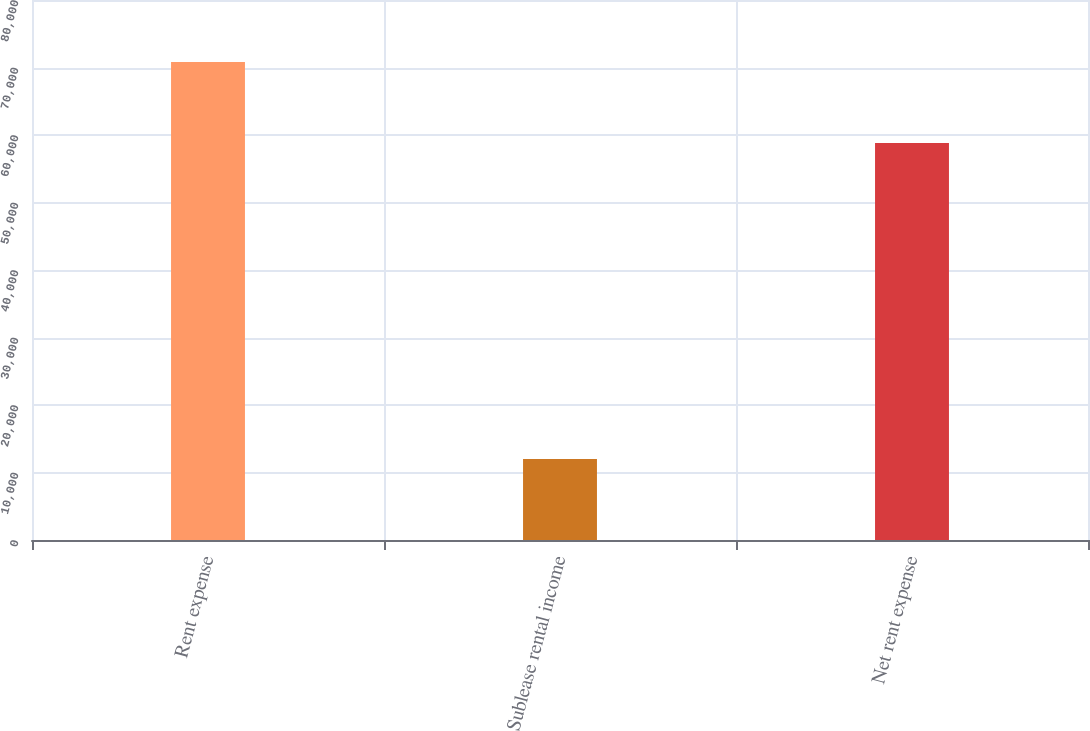<chart> <loc_0><loc_0><loc_500><loc_500><bar_chart><fcel>Rent expense<fcel>Sublease rental income<fcel>Net rent expense<nl><fcel>70815<fcel>12007<fcel>58808<nl></chart> 